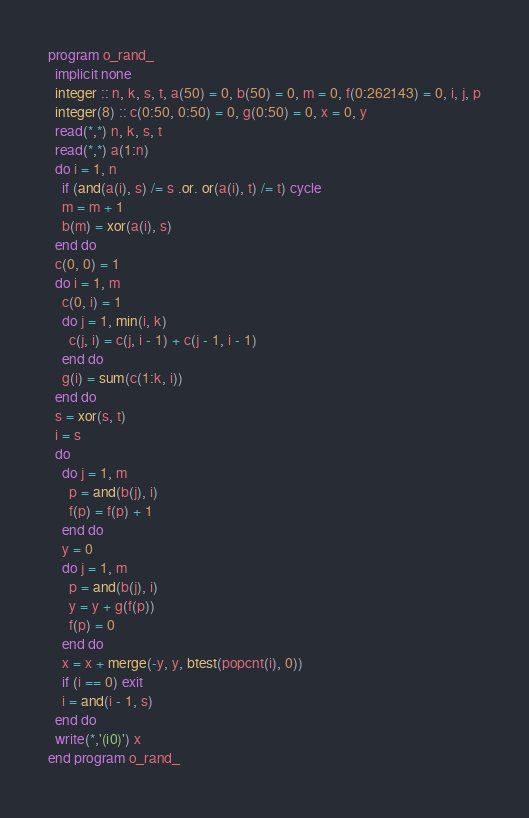Convert code to text. <code><loc_0><loc_0><loc_500><loc_500><_FORTRAN_>program o_rand_
  implicit none
  integer :: n, k, s, t, a(50) = 0, b(50) = 0, m = 0, f(0:262143) = 0, i, j, p
  integer(8) :: c(0:50, 0:50) = 0, g(0:50) = 0, x = 0, y
  read(*,*) n, k, s, t
  read(*,*) a(1:n)
  do i = 1, n
    if (and(a(i), s) /= s .or. or(a(i), t) /= t) cycle
    m = m + 1
    b(m) = xor(a(i), s)
  end do
  c(0, 0) = 1
  do i = 1, m
    c(0, i) = 1
    do j = 1, min(i, k)
      c(j, i) = c(j, i - 1) + c(j - 1, i - 1)
    end do
    g(i) = sum(c(1:k, i))
  end do
  s = xor(s, t)
  i = s
  do
    do j = 1, m
      p = and(b(j), i)
      f(p) = f(p) + 1
    end do
    y = 0
    do j = 1, m
      p = and(b(j), i)
      y = y + g(f(p))
      f(p) = 0
    end do
    x = x + merge(-y, y, btest(popcnt(i), 0))
    if (i == 0) exit
    i = and(i - 1, s)
  end do
  write(*,'(i0)') x
end program o_rand_</code> 